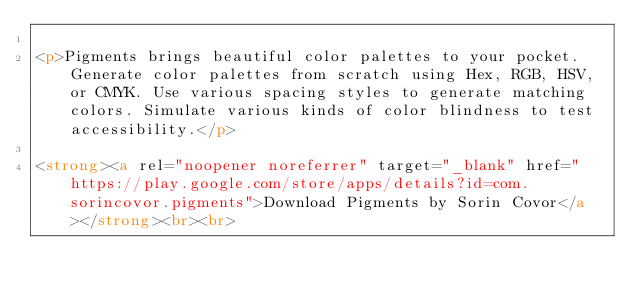Convert code to text. <code><loc_0><loc_0><loc_500><loc_500><_HTML_>
<p>Pigments brings beautiful color palettes to your pocket. Generate color palettes from scratch using Hex, RGB, HSV, or CMYK. Use various spacing styles to generate matching colors. Simulate various kinds of color blindness to test accessibility.</p>

<strong><a rel="noopener noreferrer" target="_blank" href="https://play.google.com/store/apps/details?id=com.sorincovor.pigments">Download Pigments by Sorin Covor</a></strong><br><br>
</code> 